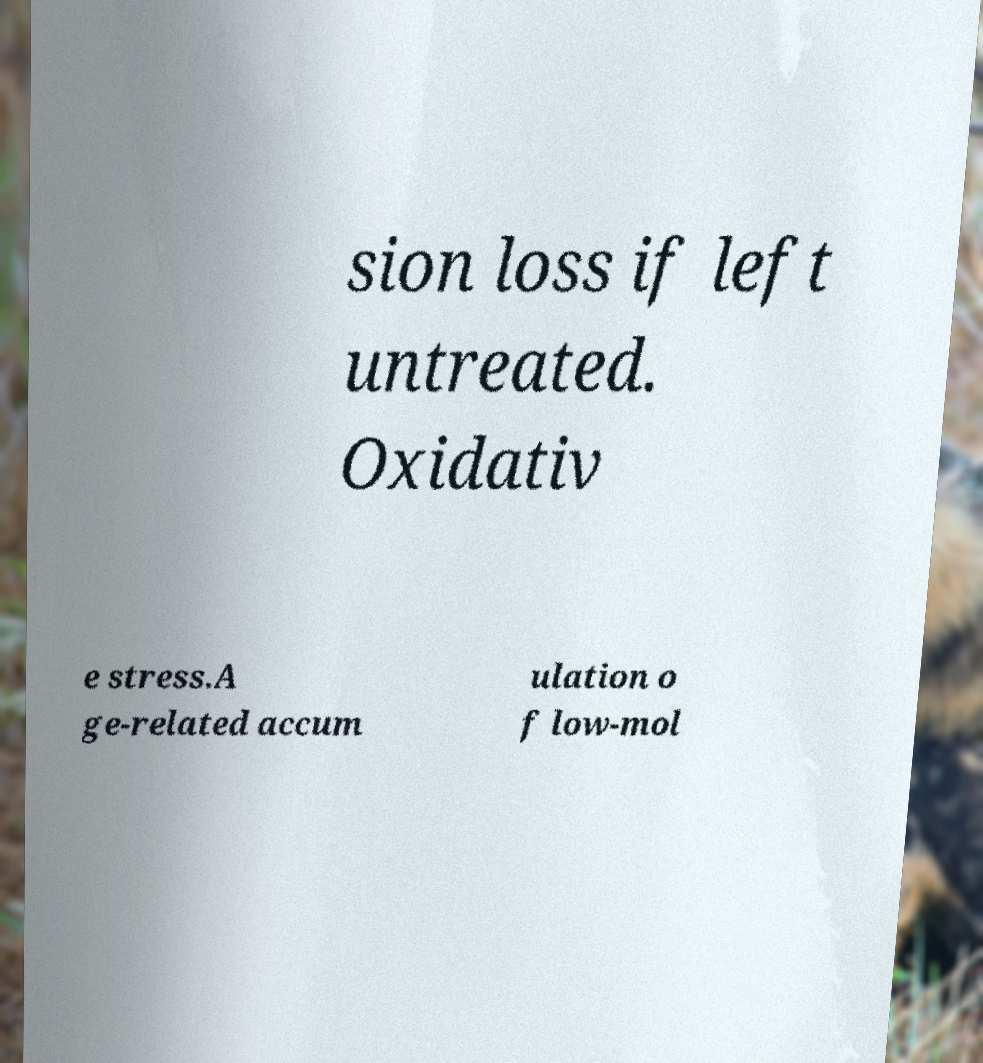Can you accurately transcribe the text from the provided image for me? sion loss if left untreated. Oxidativ e stress.A ge-related accum ulation o f low-mol 